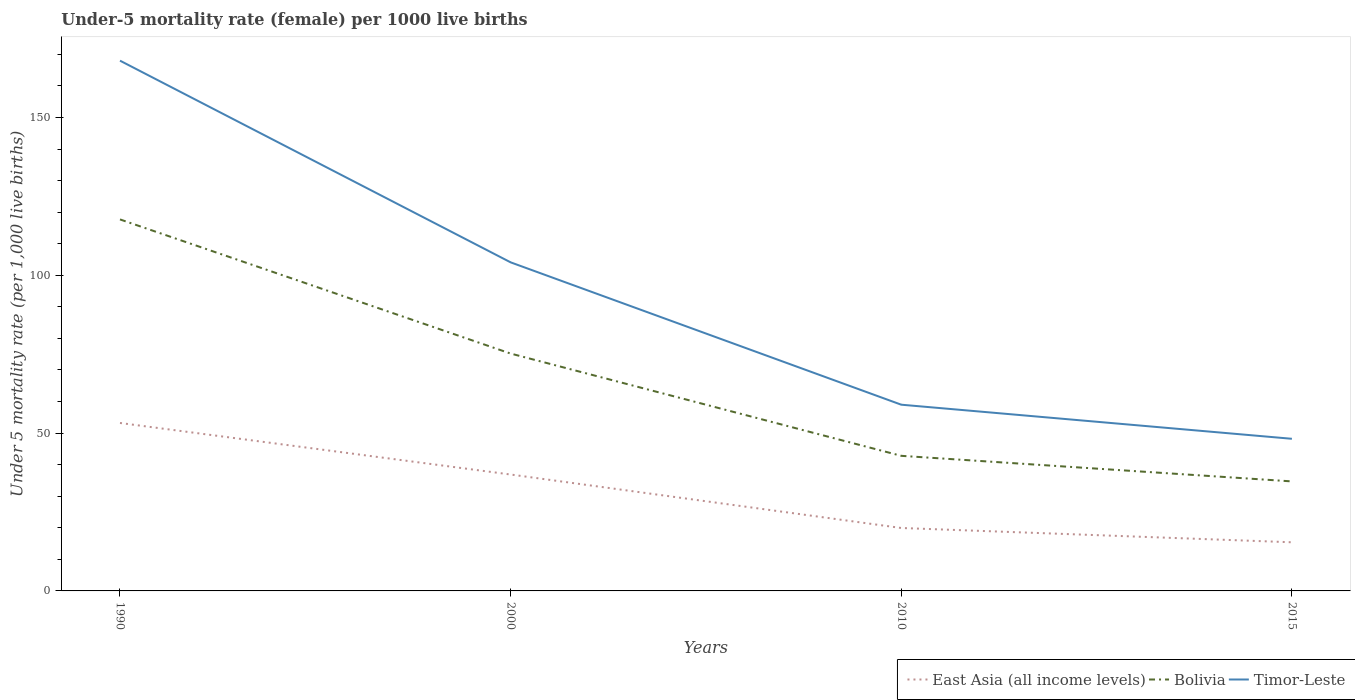Is the number of lines equal to the number of legend labels?
Keep it short and to the point. Yes. Across all years, what is the maximum under-five mortality rate in Bolivia?
Make the answer very short. 34.7. In which year was the under-five mortality rate in East Asia (all income levels) maximum?
Keep it short and to the point. 2015. What is the total under-five mortality rate in East Asia (all income levels) in the graph?
Give a very brief answer. 33.27. What is the difference between the highest and the second highest under-five mortality rate in East Asia (all income levels)?
Make the answer very short. 37.8. What is the difference between the highest and the lowest under-five mortality rate in Bolivia?
Your answer should be very brief. 2. How many lines are there?
Offer a very short reply. 3. What is the difference between two consecutive major ticks on the Y-axis?
Provide a short and direct response. 50. Does the graph contain any zero values?
Your answer should be very brief. No. Does the graph contain grids?
Make the answer very short. No. What is the title of the graph?
Keep it short and to the point. Under-5 mortality rate (female) per 1000 live births. What is the label or title of the X-axis?
Your answer should be compact. Years. What is the label or title of the Y-axis?
Provide a succinct answer. Under 5 mortality rate (per 1,0 live births). What is the Under 5 mortality rate (per 1,000 live births) of East Asia (all income levels) in 1990?
Give a very brief answer. 53.21. What is the Under 5 mortality rate (per 1,000 live births) of Bolivia in 1990?
Provide a short and direct response. 117.7. What is the Under 5 mortality rate (per 1,000 live births) of Timor-Leste in 1990?
Give a very brief answer. 168. What is the Under 5 mortality rate (per 1,000 live births) of East Asia (all income levels) in 2000?
Provide a short and direct response. 36.88. What is the Under 5 mortality rate (per 1,000 live births) in Bolivia in 2000?
Your answer should be very brief. 75.2. What is the Under 5 mortality rate (per 1,000 live births) in Timor-Leste in 2000?
Ensure brevity in your answer.  104.1. What is the Under 5 mortality rate (per 1,000 live births) in East Asia (all income levels) in 2010?
Offer a terse response. 19.94. What is the Under 5 mortality rate (per 1,000 live births) of Bolivia in 2010?
Provide a short and direct response. 42.8. What is the Under 5 mortality rate (per 1,000 live births) of East Asia (all income levels) in 2015?
Give a very brief answer. 15.41. What is the Under 5 mortality rate (per 1,000 live births) in Bolivia in 2015?
Provide a short and direct response. 34.7. What is the Under 5 mortality rate (per 1,000 live births) in Timor-Leste in 2015?
Your response must be concise. 48.2. Across all years, what is the maximum Under 5 mortality rate (per 1,000 live births) in East Asia (all income levels)?
Your answer should be compact. 53.21. Across all years, what is the maximum Under 5 mortality rate (per 1,000 live births) of Bolivia?
Provide a succinct answer. 117.7. Across all years, what is the maximum Under 5 mortality rate (per 1,000 live births) of Timor-Leste?
Give a very brief answer. 168. Across all years, what is the minimum Under 5 mortality rate (per 1,000 live births) of East Asia (all income levels)?
Keep it short and to the point. 15.41. Across all years, what is the minimum Under 5 mortality rate (per 1,000 live births) in Bolivia?
Provide a short and direct response. 34.7. Across all years, what is the minimum Under 5 mortality rate (per 1,000 live births) of Timor-Leste?
Offer a terse response. 48.2. What is the total Under 5 mortality rate (per 1,000 live births) of East Asia (all income levels) in the graph?
Provide a succinct answer. 125.44. What is the total Under 5 mortality rate (per 1,000 live births) in Bolivia in the graph?
Give a very brief answer. 270.4. What is the total Under 5 mortality rate (per 1,000 live births) of Timor-Leste in the graph?
Give a very brief answer. 379.3. What is the difference between the Under 5 mortality rate (per 1,000 live births) in East Asia (all income levels) in 1990 and that in 2000?
Offer a very short reply. 16.33. What is the difference between the Under 5 mortality rate (per 1,000 live births) of Bolivia in 1990 and that in 2000?
Keep it short and to the point. 42.5. What is the difference between the Under 5 mortality rate (per 1,000 live births) of Timor-Leste in 1990 and that in 2000?
Provide a succinct answer. 63.9. What is the difference between the Under 5 mortality rate (per 1,000 live births) of East Asia (all income levels) in 1990 and that in 2010?
Offer a very short reply. 33.27. What is the difference between the Under 5 mortality rate (per 1,000 live births) in Bolivia in 1990 and that in 2010?
Make the answer very short. 74.9. What is the difference between the Under 5 mortality rate (per 1,000 live births) in Timor-Leste in 1990 and that in 2010?
Your answer should be compact. 109. What is the difference between the Under 5 mortality rate (per 1,000 live births) of East Asia (all income levels) in 1990 and that in 2015?
Offer a terse response. 37.8. What is the difference between the Under 5 mortality rate (per 1,000 live births) of Timor-Leste in 1990 and that in 2015?
Make the answer very short. 119.8. What is the difference between the Under 5 mortality rate (per 1,000 live births) in East Asia (all income levels) in 2000 and that in 2010?
Provide a short and direct response. 16.94. What is the difference between the Under 5 mortality rate (per 1,000 live births) in Bolivia in 2000 and that in 2010?
Ensure brevity in your answer.  32.4. What is the difference between the Under 5 mortality rate (per 1,000 live births) of Timor-Leste in 2000 and that in 2010?
Your answer should be compact. 45.1. What is the difference between the Under 5 mortality rate (per 1,000 live births) in East Asia (all income levels) in 2000 and that in 2015?
Your answer should be very brief. 21.47. What is the difference between the Under 5 mortality rate (per 1,000 live births) in Bolivia in 2000 and that in 2015?
Your response must be concise. 40.5. What is the difference between the Under 5 mortality rate (per 1,000 live births) of Timor-Leste in 2000 and that in 2015?
Ensure brevity in your answer.  55.9. What is the difference between the Under 5 mortality rate (per 1,000 live births) of East Asia (all income levels) in 2010 and that in 2015?
Ensure brevity in your answer.  4.53. What is the difference between the Under 5 mortality rate (per 1,000 live births) in East Asia (all income levels) in 1990 and the Under 5 mortality rate (per 1,000 live births) in Bolivia in 2000?
Your answer should be compact. -21.99. What is the difference between the Under 5 mortality rate (per 1,000 live births) in East Asia (all income levels) in 1990 and the Under 5 mortality rate (per 1,000 live births) in Timor-Leste in 2000?
Your answer should be compact. -50.89. What is the difference between the Under 5 mortality rate (per 1,000 live births) of East Asia (all income levels) in 1990 and the Under 5 mortality rate (per 1,000 live births) of Bolivia in 2010?
Give a very brief answer. 10.41. What is the difference between the Under 5 mortality rate (per 1,000 live births) of East Asia (all income levels) in 1990 and the Under 5 mortality rate (per 1,000 live births) of Timor-Leste in 2010?
Offer a very short reply. -5.79. What is the difference between the Under 5 mortality rate (per 1,000 live births) in Bolivia in 1990 and the Under 5 mortality rate (per 1,000 live births) in Timor-Leste in 2010?
Your response must be concise. 58.7. What is the difference between the Under 5 mortality rate (per 1,000 live births) in East Asia (all income levels) in 1990 and the Under 5 mortality rate (per 1,000 live births) in Bolivia in 2015?
Provide a short and direct response. 18.51. What is the difference between the Under 5 mortality rate (per 1,000 live births) in East Asia (all income levels) in 1990 and the Under 5 mortality rate (per 1,000 live births) in Timor-Leste in 2015?
Give a very brief answer. 5.01. What is the difference between the Under 5 mortality rate (per 1,000 live births) in Bolivia in 1990 and the Under 5 mortality rate (per 1,000 live births) in Timor-Leste in 2015?
Your answer should be very brief. 69.5. What is the difference between the Under 5 mortality rate (per 1,000 live births) of East Asia (all income levels) in 2000 and the Under 5 mortality rate (per 1,000 live births) of Bolivia in 2010?
Offer a terse response. -5.92. What is the difference between the Under 5 mortality rate (per 1,000 live births) of East Asia (all income levels) in 2000 and the Under 5 mortality rate (per 1,000 live births) of Timor-Leste in 2010?
Offer a very short reply. -22.12. What is the difference between the Under 5 mortality rate (per 1,000 live births) of Bolivia in 2000 and the Under 5 mortality rate (per 1,000 live births) of Timor-Leste in 2010?
Offer a very short reply. 16.2. What is the difference between the Under 5 mortality rate (per 1,000 live births) in East Asia (all income levels) in 2000 and the Under 5 mortality rate (per 1,000 live births) in Bolivia in 2015?
Your answer should be very brief. 2.18. What is the difference between the Under 5 mortality rate (per 1,000 live births) of East Asia (all income levels) in 2000 and the Under 5 mortality rate (per 1,000 live births) of Timor-Leste in 2015?
Your response must be concise. -11.32. What is the difference between the Under 5 mortality rate (per 1,000 live births) of East Asia (all income levels) in 2010 and the Under 5 mortality rate (per 1,000 live births) of Bolivia in 2015?
Your answer should be compact. -14.76. What is the difference between the Under 5 mortality rate (per 1,000 live births) of East Asia (all income levels) in 2010 and the Under 5 mortality rate (per 1,000 live births) of Timor-Leste in 2015?
Your answer should be very brief. -28.26. What is the difference between the Under 5 mortality rate (per 1,000 live births) in Bolivia in 2010 and the Under 5 mortality rate (per 1,000 live births) in Timor-Leste in 2015?
Your answer should be compact. -5.4. What is the average Under 5 mortality rate (per 1,000 live births) in East Asia (all income levels) per year?
Your answer should be compact. 31.36. What is the average Under 5 mortality rate (per 1,000 live births) in Bolivia per year?
Offer a terse response. 67.6. What is the average Under 5 mortality rate (per 1,000 live births) in Timor-Leste per year?
Make the answer very short. 94.83. In the year 1990, what is the difference between the Under 5 mortality rate (per 1,000 live births) in East Asia (all income levels) and Under 5 mortality rate (per 1,000 live births) in Bolivia?
Your answer should be compact. -64.49. In the year 1990, what is the difference between the Under 5 mortality rate (per 1,000 live births) of East Asia (all income levels) and Under 5 mortality rate (per 1,000 live births) of Timor-Leste?
Provide a succinct answer. -114.79. In the year 1990, what is the difference between the Under 5 mortality rate (per 1,000 live births) of Bolivia and Under 5 mortality rate (per 1,000 live births) of Timor-Leste?
Give a very brief answer. -50.3. In the year 2000, what is the difference between the Under 5 mortality rate (per 1,000 live births) of East Asia (all income levels) and Under 5 mortality rate (per 1,000 live births) of Bolivia?
Your answer should be compact. -38.32. In the year 2000, what is the difference between the Under 5 mortality rate (per 1,000 live births) of East Asia (all income levels) and Under 5 mortality rate (per 1,000 live births) of Timor-Leste?
Ensure brevity in your answer.  -67.22. In the year 2000, what is the difference between the Under 5 mortality rate (per 1,000 live births) in Bolivia and Under 5 mortality rate (per 1,000 live births) in Timor-Leste?
Offer a very short reply. -28.9. In the year 2010, what is the difference between the Under 5 mortality rate (per 1,000 live births) in East Asia (all income levels) and Under 5 mortality rate (per 1,000 live births) in Bolivia?
Offer a terse response. -22.86. In the year 2010, what is the difference between the Under 5 mortality rate (per 1,000 live births) in East Asia (all income levels) and Under 5 mortality rate (per 1,000 live births) in Timor-Leste?
Provide a short and direct response. -39.06. In the year 2010, what is the difference between the Under 5 mortality rate (per 1,000 live births) of Bolivia and Under 5 mortality rate (per 1,000 live births) of Timor-Leste?
Make the answer very short. -16.2. In the year 2015, what is the difference between the Under 5 mortality rate (per 1,000 live births) of East Asia (all income levels) and Under 5 mortality rate (per 1,000 live births) of Bolivia?
Your answer should be compact. -19.29. In the year 2015, what is the difference between the Under 5 mortality rate (per 1,000 live births) of East Asia (all income levels) and Under 5 mortality rate (per 1,000 live births) of Timor-Leste?
Provide a succinct answer. -32.79. In the year 2015, what is the difference between the Under 5 mortality rate (per 1,000 live births) in Bolivia and Under 5 mortality rate (per 1,000 live births) in Timor-Leste?
Give a very brief answer. -13.5. What is the ratio of the Under 5 mortality rate (per 1,000 live births) of East Asia (all income levels) in 1990 to that in 2000?
Ensure brevity in your answer.  1.44. What is the ratio of the Under 5 mortality rate (per 1,000 live births) in Bolivia in 1990 to that in 2000?
Offer a very short reply. 1.57. What is the ratio of the Under 5 mortality rate (per 1,000 live births) of Timor-Leste in 1990 to that in 2000?
Keep it short and to the point. 1.61. What is the ratio of the Under 5 mortality rate (per 1,000 live births) of East Asia (all income levels) in 1990 to that in 2010?
Keep it short and to the point. 2.67. What is the ratio of the Under 5 mortality rate (per 1,000 live births) of Bolivia in 1990 to that in 2010?
Offer a terse response. 2.75. What is the ratio of the Under 5 mortality rate (per 1,000 live births) of Timor-Leste in 1990 to that in 2010?
Your answer should be very brief. 2.85. What is the ratio of the Under 5 mortality rate (per 1,000 live births) in East Asia (all income levels) in 1990 to that in 2015?
Make the answer very short. 3.45. What is the ratio of the Under 5 mortality rate (per 1,000 live births) in Bolivia in 1990 to that in 2015?
Provide a succinct answer. 3.39. What is the ratio of the Under 5 mortality rate (per 1,000 live births) of Timor-Leste in 1990 to that in 2015?
Your answer should be very brief. 3.49. What is the ratio of the Under 5 mortality rate (per 1,000 live births) of East Asia (all income levels) in 2000 to that in 2010?
Your answer should be very brief. 1.85. What is the ratio of the Under 5 mortality rate (per 1,000 live births) of Bolivia in 2000 to that in 2010?
Make the answer very short. 1.76. What is the ratio of the Under 5 mortality rate (per 1,000 live births) in Timor-Leste in 2000 to that in 2010?
Provide a short and direct response. 1.76. What is the ratio of the Under 5 mortality rate (per 1,000 live births) in East Asia (all income levels) in 2000 to that in 2015?
Ensure brevity in your answer.  2.39. What is the ratio of the Under 5 mortality rate (per 1,000 live births) of Bolivia in 2000 to that in 2015?
Keep it short and to the point. 2.17. What is the ratio of the Under 5 mortality rate (per 1,000 live births) in Timor-Leste in 2000 to that in 2015?
Keep it short and to the point. 2.16. What is the ratio of the Under 5 mortality rate (per 1,000 live births) in East Asia (all income levels) in 2010 to that in 2015?
Keep it short and to the point. 1.29. What is the ratio of the Under 5 mortality rate (per 1,000 live births) in Bolivia in 2010 to that in 2015?
Give a very brief answer. 1.23. What is the ratio of the Under 5 mortality rate (per 1,000 live births) of Timor-Leste in 2010 to that in 2015?
Offer a very short reply. 1.22. What is the difference between the highest and the second highest Under 5 mortality rate (per 1,000 live births) of East Asia (all income levels)?
Your answer should be compact. 16.33. What is the difference between the highest and the second highest Under 5 mortality rate (per 1,000 live births) of Bolivia?
Your response must be concise. 42.5. What is the difference between the highest and the second highest Under 5 mortality rate (per 1,000 live births) in Timor-Leste?
Give a very brief answer. 63.9. What is the difference between the highest and the lowest Under 5 mortality rate (per 1,000 live births) in East Asia (all income levels)?
Make the answer very short. 37.8. What is the difference between the highest and the lowest Under 5 mortality rate (per 1,000 live births) in Bolivia?
Provide a succinct answer. 83. What is the difference between the highest and the lowest Under 5 mortality rate (per 1,000 live births) in Timor-Leste?
Ensure brevity in your answer.  119.8. 